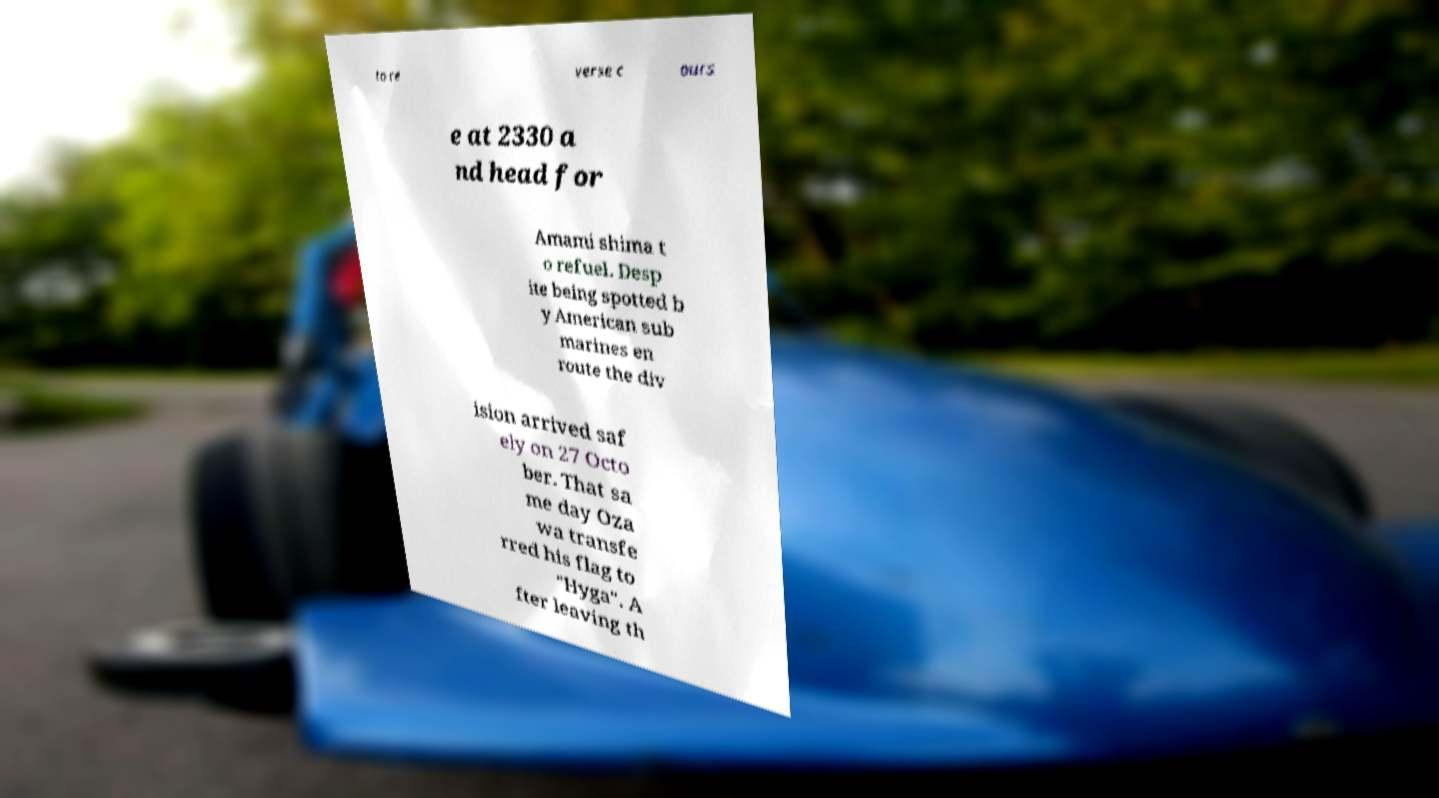Please identify and transcribe the text found in this image. to re verse c ours e at 2330 a nd head for Amami shima t o refuel. Desp ite being spotted b y American sub marines en route the div ision arrived saf ely on 27 Octo ber. That sa me day Oza wa transfe rred his flag to "Hyga". A fter leaving th 